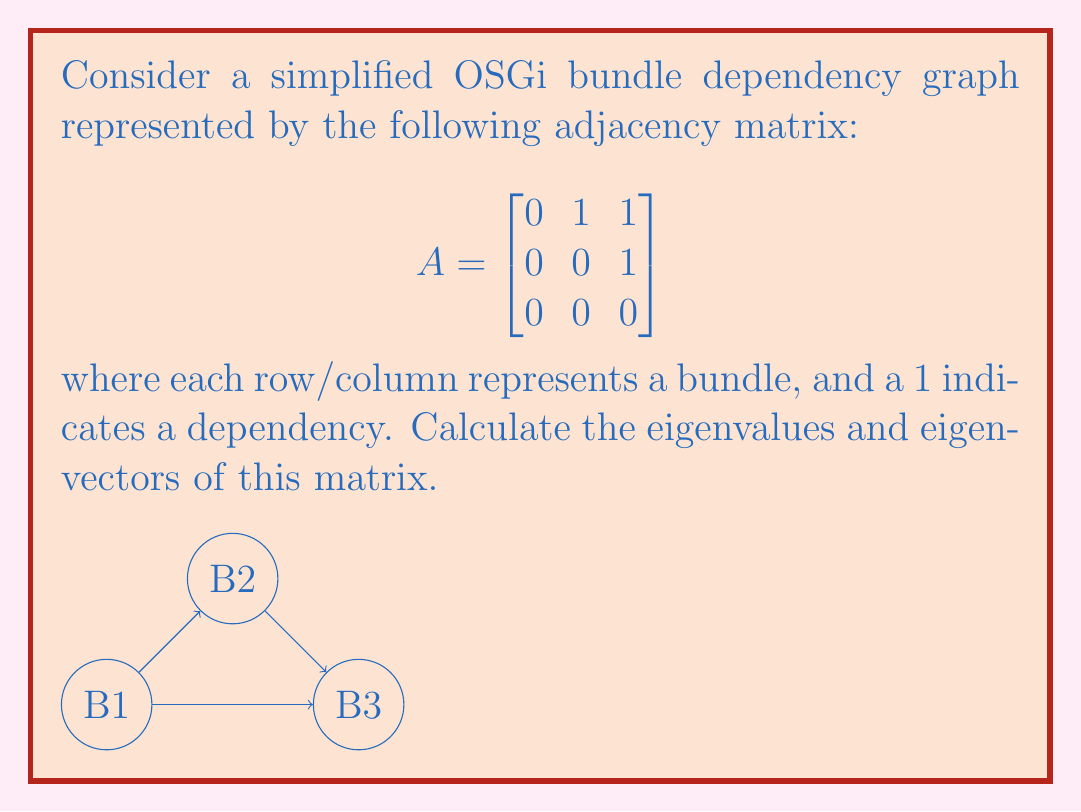Can you solve this math problem? To find the eigenvalues and eigenvectors, we'll follow these steps:

1) Find the characteristic equation:
   $$det(A - \lambda I) = 0$$
   
   $$\begin{vmatrix}
   -\lambda & 1 & 1 \\
   0 & -\lambda & 1 \\
   0 & 0 & -\lambda
   \end{vmatrix} = 0$$

2) Expand the determinant:
   $$-\lambda(-\lambda)(-\lambda) = 0$$
   $$-\lambda^3 = 0$$

3) Solve for λ:
   $$\lambda = 0$$ (with algebraic multiplicity 3)

4) For each eigenvalue, find the eigenvectors by solving $(A - \lambda I)\vec{v} = \vec{0}$:

   For $\lambda = 0$:
   $$\begin{bmatrix}
   0 & 1 & 1 \\
   0 & 0 & 1 \\
   0 & 0 & 0
   \end{bmatrix}\begin{bmatrix}
   v_1 \\ v_2 \\ v_3
   \end{bmatrix} = \begin{bmatrix}
   0 \\ 0 \\ 0
   \end{bmatrix}$$

   This gives us:
   $$v_2 + v_3 = 0$$
   $$v_3 = 0$$

5) Solving this system:
   $v_3 = 0$
   $v_2 = 0$
   $v_1$ is free

   Therefore, the eigenvector is:
   $$\vec{v} = \begin{bmatrix}
   1 \\ 0 \\ 0
   \end{bmatrix}$$

Note: The eigenspace is one-dimensional despite the algebraic multiplicity of 3, indicating that this matrix is not diagonalizable.
Answer: Eigenvalue: $\lambda = 0$ (multiplicity 3)
Eigenvector: $\vec{v} = \begin{bmatrix} 1 \\ 0 \\ 0 \end{bmatrix}$ 